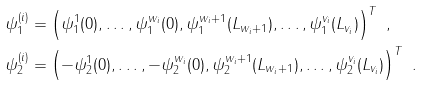<formula> <loc_0><loc_0><loc_500><loc_500>\psi _ { 1 } ^ { ( i ) } & = \left ( \psi _ { 1 } ^ { 1 } ( 0 ) , \dots , \psi _ { 1 } ^ { w _ { i } } ( 0 ) , \psi _ { 1 } ^ { w _ { i } + 1 } ( L _ { w _ { i } + 1 } ) , \dots , \psi _ { 1 } ^ { v _ { i } } ( L _ { v _ { i } } ) \right ) ^ { T } \ , \\ \psi _ { 2 } ^ { ( i ) } & = \left ( - \psi _ { 2 } ^ { 1 } ( 0 ) , \dots , - \psi _ { 2 } ^ { w _ { i } } ( 0 ) , \psi _ { 2 } ^ { w _ { i } + 1 } ( L _ { w _ { i } + 1 } ) , \dots , \psi _ { 2 } ^ { v _ { i } } ( L _ { v _ { i } } ) \right ) ^ { T } \ .</formula> 